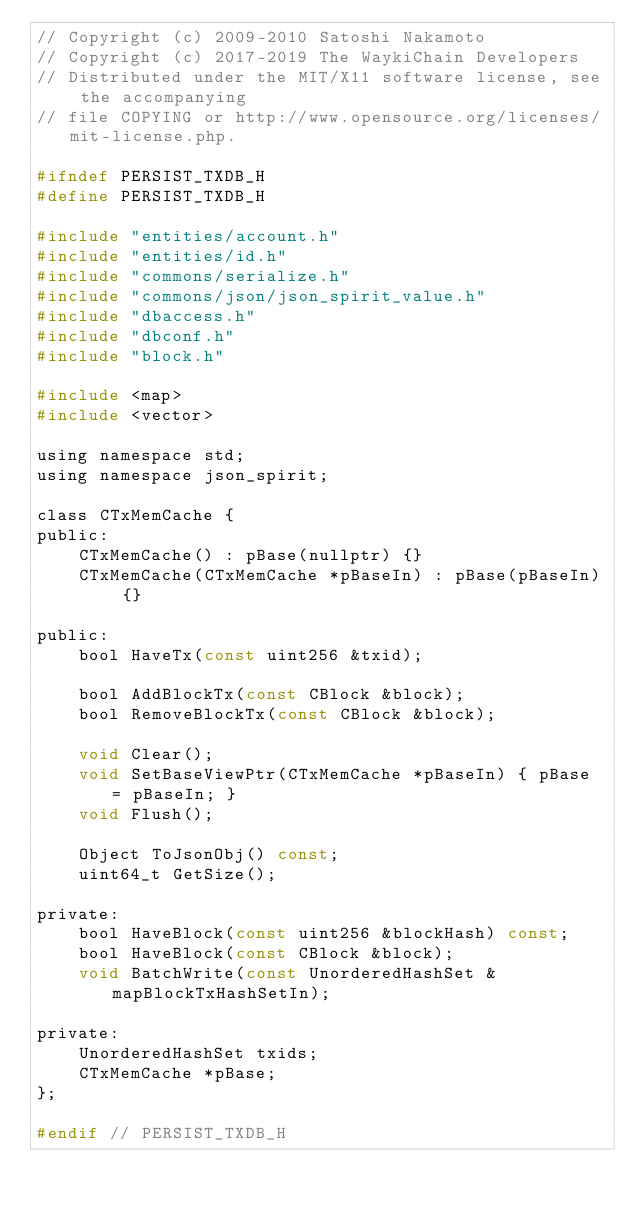<code> <loc_0><loc_0><loc_500><loc_500><_C_>// Copyright (c) 2009-2010 Satoshi Nakamoto
// Copyright (c) 2017-2019 The WaykiChain Developers
// Distributed under the MIT/X11 software license, see the accompanying
// file COPYING or http://www.opensource.org/licenses/mit-license.php.

#ifndef PERSIST_TXDB_H
#define PERSIST_TXDB_H

#include "entities/account.h"
#include "entities/id.h"
#include "commons/serialize.h"
#include "commons/json/json_spirit_value.h"
#include "dbaccess.h"
#include "dbconf.h"
#include "block.h"

#include <map>
#include <vector>

using namespace std;
using namespace json_spirit;

class CTxMemCache {
public:
    CTxMemCache() : pBase(nullptr) {}
    CTxMemCache(CTxMemCache *pBaseIn) : pBase(pBaseIn) {}

public:
    bool HaveTx(const uint256 &txid);

    bool AddBlockTx(const CBlock &block);
    bool RemoveBlockTx(const CBlock &block);

    void Clear();
    void SetBaseViewPtr(CTxMemCache *pBaseIn) { pBase = pBaseIn; }
    void Flush();

    Object ToJsonObj() const;
    uint64_t GetSize();

private:
    bool HaveBlock(const uint256 &blockHash) const;
    bool HaveBlock(const CBlock &block);
    void BatchWrite(const UnorderedHashSet &mapBlockTxHashSetIn);

private:
    UnorderedHashSet txids;
    CTxMemCache *pBase;
};

#endif // PERSIST_TXDB_H</code> 